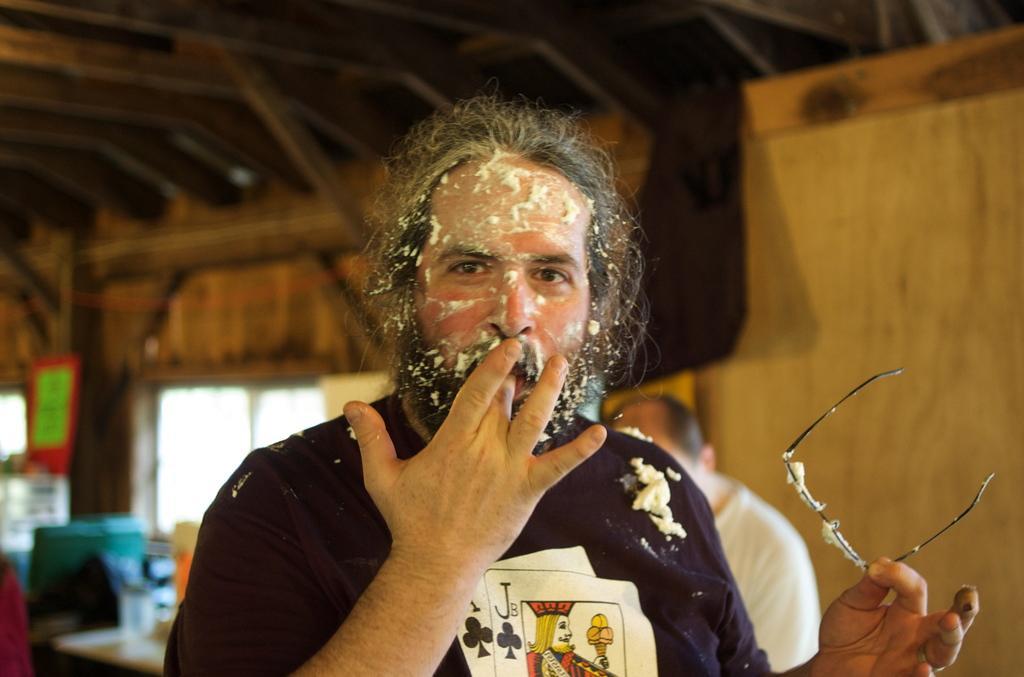Please provide a concise description of this image. In this picture we can see a man holding a spectacle with his hand and in the background we can see a window, wall, poster and some objects. 